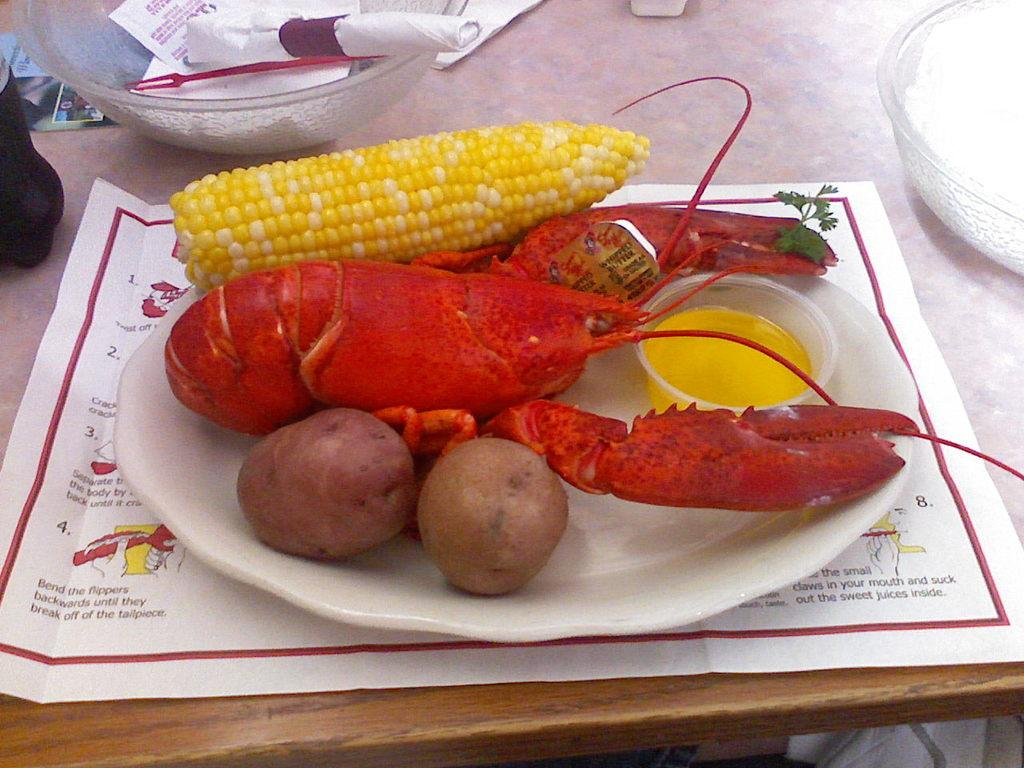What is on the plate in the image? There are food items on the plate in the image. What else can be seen on the table besides the plate? There are bowls and a paper on the table. What type of toothbrush is used to stir the honey in the image? There is no toothbrush or honey present in the image. 